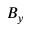Convert formula to latex. <formula><loc_0><loc_0><loc_500><loc_500>B _ { y }</formula> 